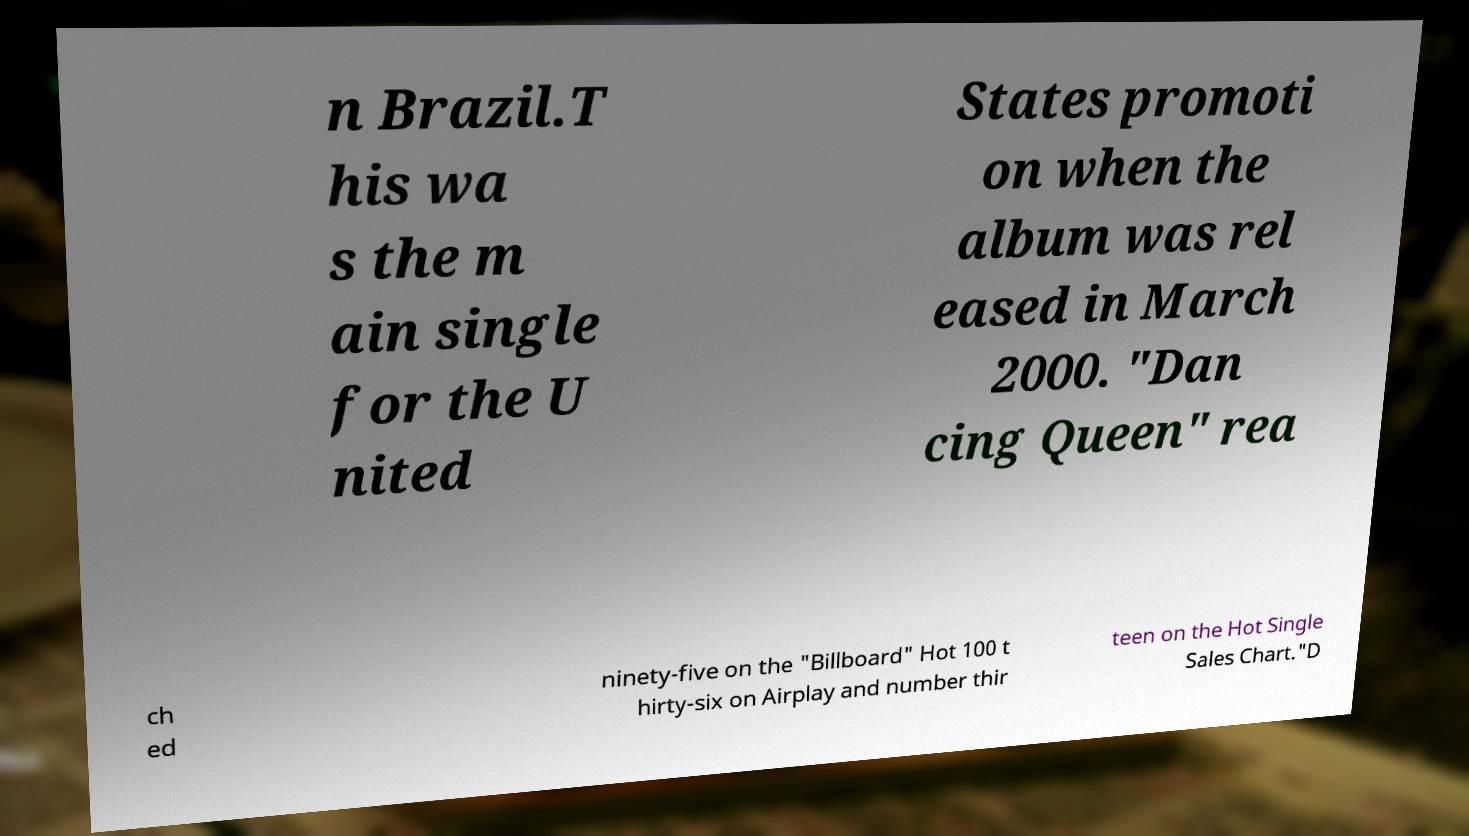Could you assist in decoding the text presented in this image and type it out clearly? n Brazil.T his wa s the m ain single for the U nited States promoti on when the album was rel eased in March 2000. "Dan cing Queen" rea ch ed ninety-five on the "Billboard" Hot 100 t hirty-six on Airplay and number thir teen on the Hot Single Sales Chart."D 